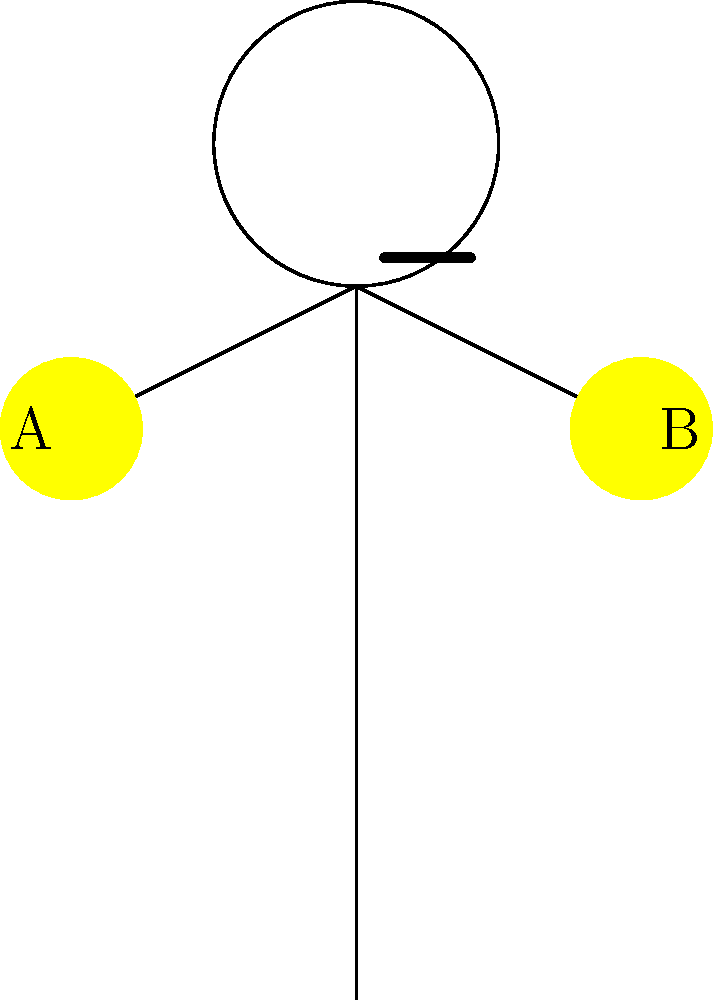In a football match, the referee holds both arms outstretched as shown in the diagram. What does this signal typically indicate? To interpret this referee signal, let's break it down step-by-step:

1. The referee's posture: The diagram shows the referee with both arms outstretched horizontally.

2. Hand position: Both hands (labeled A and B) are at the same level, forming a straight line.

3. Common football signals:
   a) One arm raised: Indirect free kick
   b) One arm pointed: Direct free kick
   c) Both arms raised above head: Goal
   d) Both arms outstretched horizontally: Advantage play

4. Meaning of this signal: When a referee holds both arms outstretched horizontally, it indicates that they are allowing play to continue despite a potential foul. This is known as the "advantage rule" or "playing advantage."

5. Purpose of the advantage rule: It allows the game to flow without unnecessary stoppages when the fouled team may benefit more from continuing play than from a free kick.

6. Application in the game: If the advantage doesn't materialize within a few seconds, the referee may still call the original foul.

Therefore, based on the referee's arm position in the diagram, this signal indicates that the referee is playing advantage.
Answer: Playing advantage 